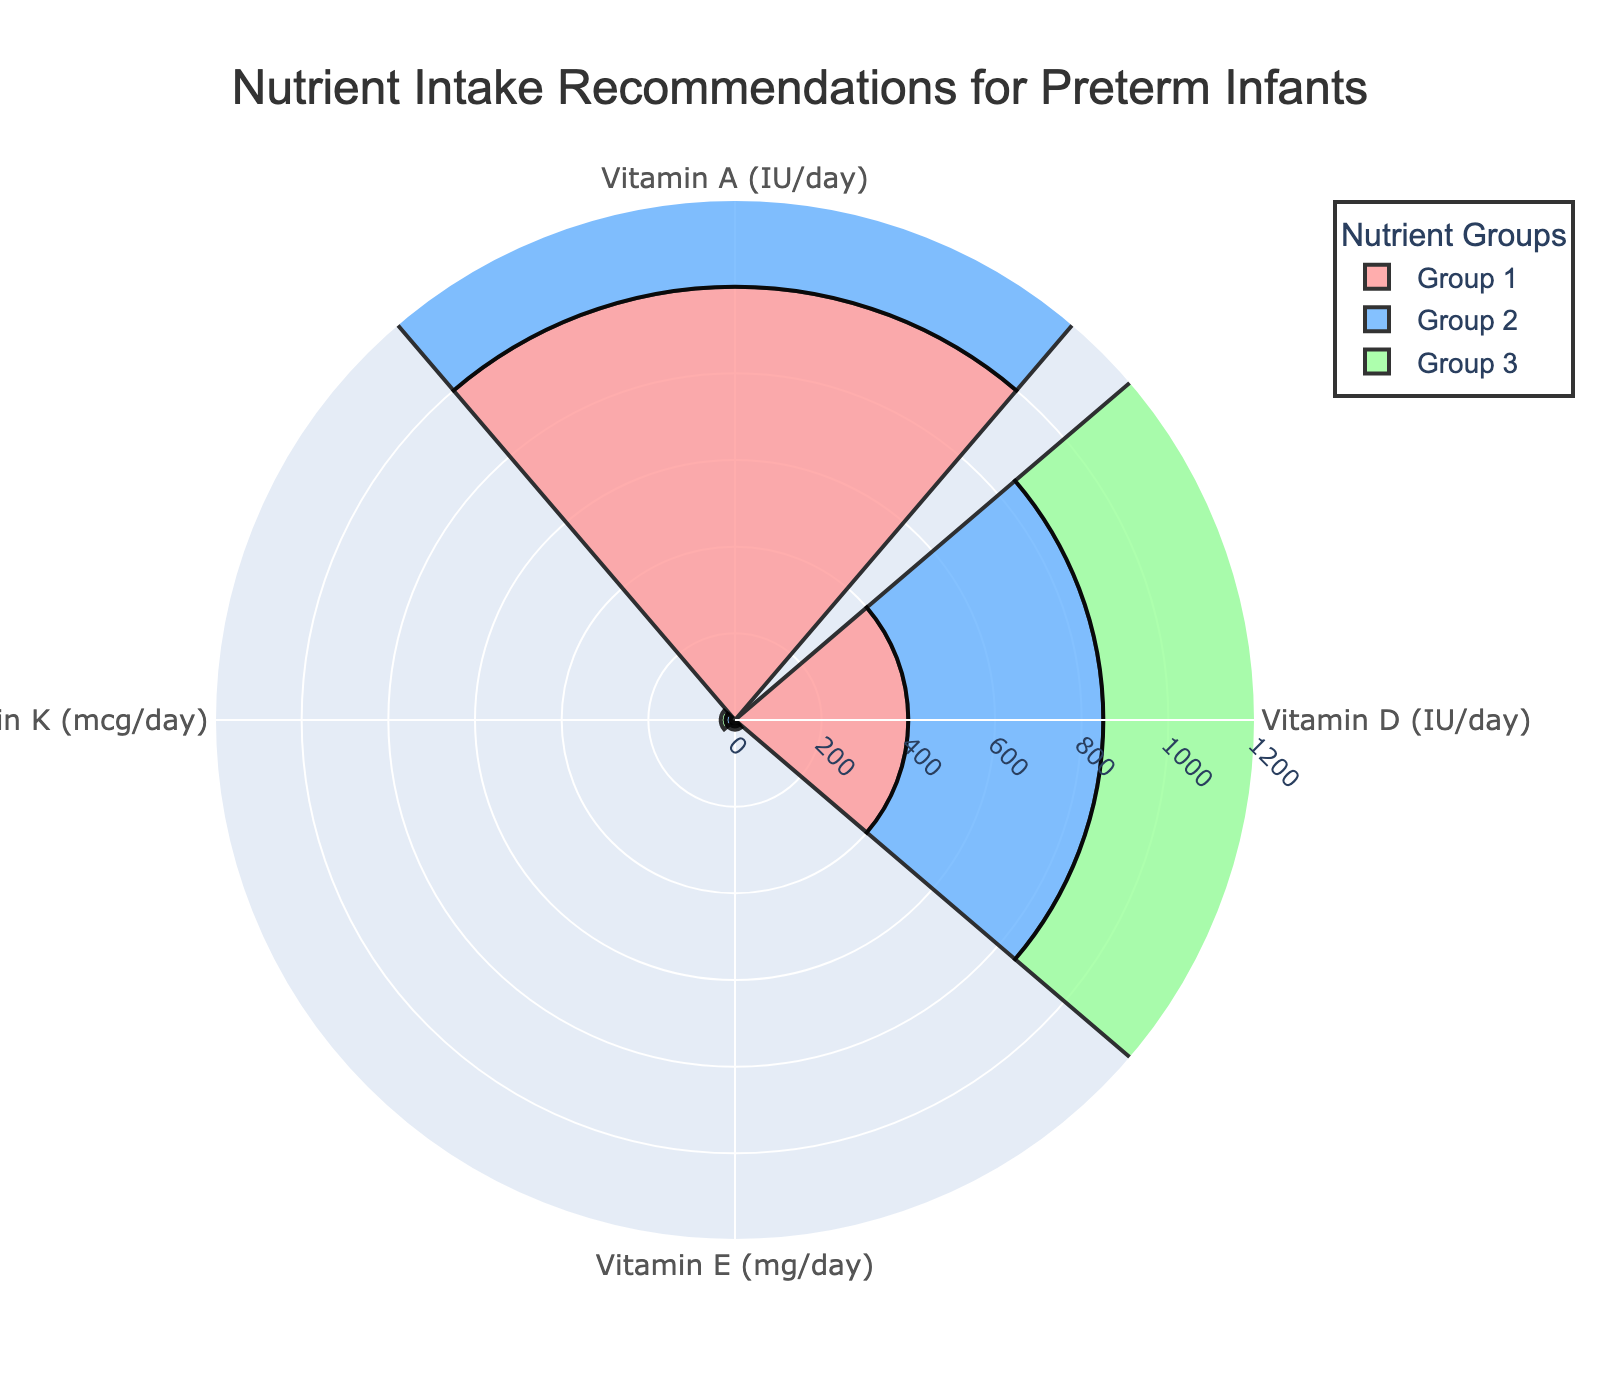What is the title of the figure? The title is found at the top of the figure and usually describes what the chart is about. In this case, the title is visible on the chart.
Answer: Nutrient Intake Recommendations for Preterm Infants How many nutrients are represented in the figure? By examining the chart, you can count the different segments labeled for each nutrient group. Here, three groups are shown, each in a different color.
Answer: Three Which nutrient group has the highest recommendation for Vitamin A? By looking at the length of the bars in the 'Vitamin A' category and identifying the longest bar, you can determine which group it represents. In this case, the longest bar corresponds to Group 2.
Answer: Group 2 What is the range shown in the radial axis? To find the range, you look at the values provided along the radial axis. Here, it is visible in the chart.
Answer: 0 to 1200 Which vitamin has the closest recommendation values across the three nutrient groups? By comparing the lengths of the bars in each vitamin category, we observe that the differences in values for 'Vitamin E' across all three groups are relatively small.
Answer: Vitamin E What is the total intake of Vitamin D for all three groups combined? Add the Vitamin D values for Group 1 (400), Group 2 (450), and Group 3 (430). The total is 400 + 450 + 430 = 1280.
Answer: 1280 Which nutrient group has the smallest recommendation for Vitamin K? By identifying the shortest bar in the 'Vitamin K' category, it corresponds to Group 1.
Answer: Group 1 What is the average recommendation for Vitamin A across the three nutrient groups? Add the Vitamin A values for Group 1 (1000), Group 2 (1200), and Group 3 (1100), and then divide by 3. The calculation is (1000 + 1200 + 1100) / 3 = 1100.
Answer: 1100 Is there any nutrient group that has the same recommended intake value for any of the vitamins? Compare each vitamin category across the different nutrient groups to see if any values match. In this case, there is no instance of matching values across the groups for any vitamin.
Answer: No 